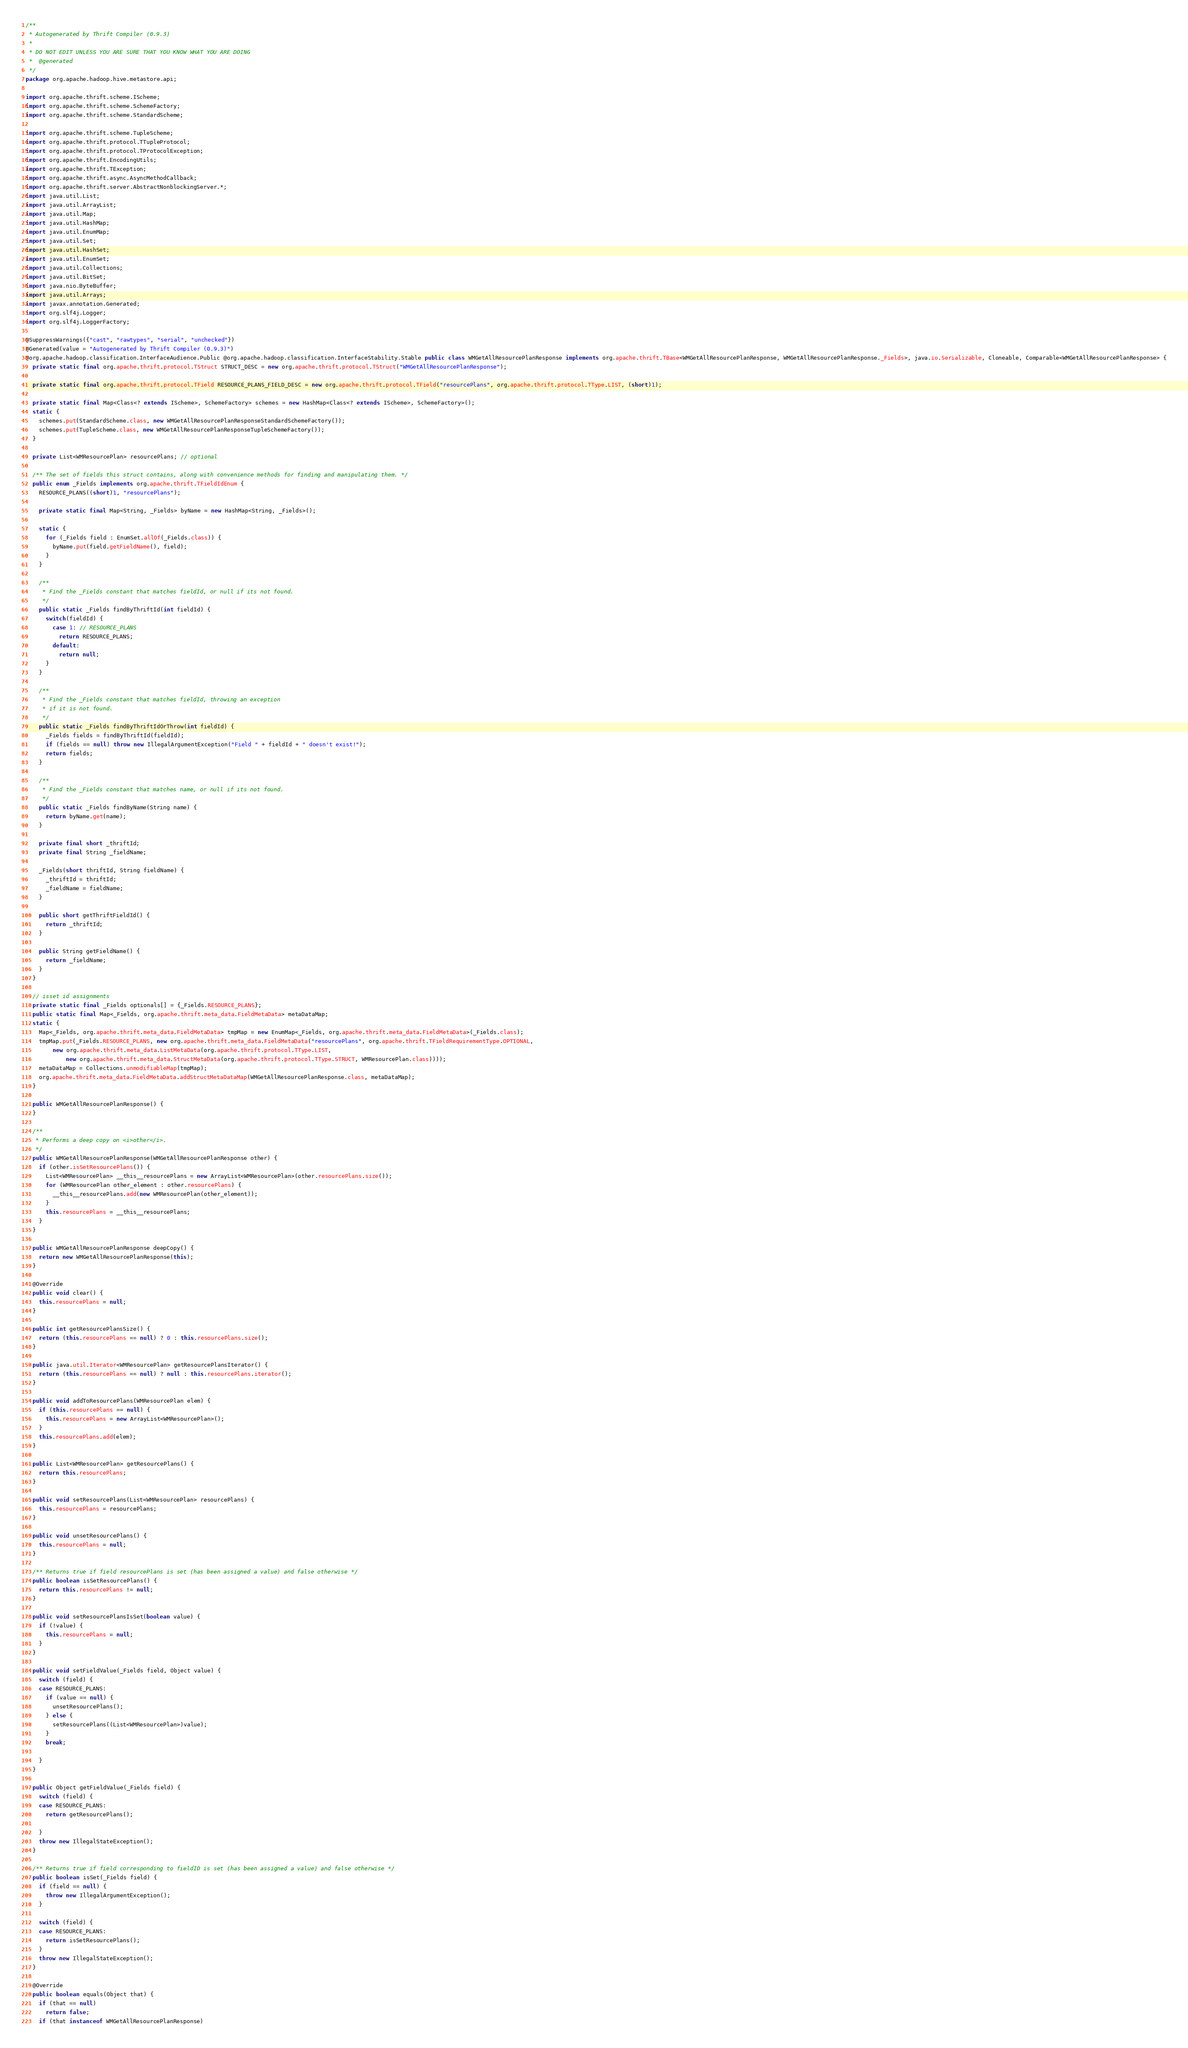Convert code to text. <code><loc_0><loc_0><loc_500><loc_500><_Java_>/**
 * Autogenerated by Thrift Compiler (0.9.3)
 *
 * DO NOT EDIT UNLESS YOU ARE SURE THAT YOU KNOW WHAT YOU ARE DOING
 *  @generated
 */
package org.apache.hadoop.hive.metastore.api;

import org.apache.thrift.scheme.IScheme;
import org.apache.thrift.scheme.SchemeFactory;
import org.apache.thrift.scheme.StandardScheme;

import org.apache.thrift.scheme.TupleScheme;
import org.apache.thrift.protocol.TTupleProtocol;
import org.apache.thrift.protocol.TProtocolException;
import org.apache.thrift.EncodingUtils;
import org.apache.thrift.TException;
import org.apache.thrift.async.AsyncMethodCallback;
import org.apache.thrift.server.AbstractNonblockingServer.*;
import java.util.List;
import java.util.ArrayList;
import java.util.Map;
import java.util.HashMap;
import java.util.EnumMap;
import java.util.Set;
import java.util.HashSet;
import java.util.EnumSet;
import java.util.Collections;
import java.util.BitSet;
import java.nio.ByteBuffer;
import java.util.Arrays;
import javax.annotation.Generated;
import org.slf4j.Logger;
import org.slf4j.LoggerFactory;

@SuppressWarnings({"cast", "rawtypes", "serial", "unchecked"})
@Generated(value = "Autogenerated by Thrift Compiler (0.9.3)")
@org.apache.hadoop.classification.InterfaceAudience.Public @org.apache.hadoop.classification.InterfaceStability.Stable public class WMGetAllResourcePlanResponse implements org.apache.thrift.TBase<WMGetAllResourcePlanResponse, WMGetAllResourcePlanResponse._Fields>, java.io.Serializable, Cloneable, Comparable<WMGetAllResourcePlanResponse> {
  private static final org.apache.thrift.protocol.TStruct STRUCT_DESC = new org.apache.thrift.protocol.TStruct("WMGetAllResourcePlanResponse");

  private static final org.apache.thrift.protocol.TField RESOURCE_PLANS_FIELD_DESC = new org.apache.thrift.protocol.TField("resourcePlans", org.apache.thrift.protocol.TType.LIST, (short)1);

  private static final Map<Class<? extends IScheme>, SchemeFactory> schemes = new HashMap<Class<? extends IScheme>, SchemeFactory>();
  static {
    schemes.put(StandardScheme.class, new WMGetAllResourcePlanResponseStandardSchemeFactory());
    schemes.put(TupleScheme.class, new WMGetAllResourcePlanResponseTupleSchemeFactory());
  }

  private List<WMResourcePlan> resourcePlans; // optional

  /** The set of fields this struct contains, along with convenience methods for finding and manipulating them. */
  public enum _Fields implements org.apache.thrift.TFieldIdEnum {
    RESOURCE_PLANS((short)1, "resourcePlans");

    private static final Map<String, _Fields> byName = new HashMap<String, _Fields>();

    static {
      for (_Fields field : EnumSet.allOf(_Fields.class)) {
        byName.put(field.getFieldName(), field);
      }
    }

    /**
     * Find the _Fields constant that matches fieldId, or null if its not found.
     */
    public static _Fields findByThriftId(int fieldId) {
      switch(fieldId) {
        case 1: // RESOURCE_PLANS
          return RESOURCE_PLANS;
        default:
          return null;
      }
    }

    /**
     * Find the _Fields constant that matches fieldId, throwing an exception
     * if it is not found.
     */
    public static _Fields findByThriftIdOrThrow(int fieldId) {
      _Fields fields = findByThriftId(fieldId);
      if (fields == null) throw new IllegalArgumentException("Field " + fieldId + " doesn't exist!");
      return fields;
    }

    /**
     * Find the _Fields constant that matches name, or null if its not found.
     */
    public static _Fields findByName(String name) {
      return byName.get(name);
    }

    private final short _thriftId;
    private final String _fieldName;

    _Fields(short thriftId, String fieldName) {
      _thriftId = thriftId;
      _fieldName = fieldName;
    }

    public short getThriftFieldId() {
      return _thriftId;
    }

    public String getFieldName() {
      return _fieldName;
    }
  }

  // isset id assignments
  private static final _Fields optionals[] = {_Fields.RESOURCE_PLANS};
  public static final Map<_Fields, org.apache.thrift.meta_data.FieldMetaData> metaDataMap;
  static {
    Map<_Fields, org.apache.thrift.meta_data.FieldMetaData> tmpMap = new EnumMap<_Fields, org.apache.thrift.meta_data.FieldMetaData>(_Fields.class);
    tmpMap.put(_Fields.RESOURCE_PLANS, new org.apache.thrift.meta_data.FieldMetaData("resourcePlans", org.apache.thrift.TFieldRequirementType.OPTIONAL, 
        new org.apache.thrift.meta_data.ListMetaData(org.apache.thrift.protocol.TType.LIST, 
            new org.apache.thrift.meta_data.StructMetaData(org.apache.thrift.protocol.TType.STRUCT, WMResourcePlan.class))));
    metaDataMap = Collections.unmodifiableMap(tmpMap);
    org.apache.thrift.meta_data.FieldMetaData.addStructMetaDataMap(WMGetAllResourcePlanResponse.class, metaDataMap);
  }

  public WMGetAllResourcePlanResponse() {
  }

  /**
   * Performs a deep copy on <i>other</i>.
   */
  public WMGetAllResourcePlanResponse(WMGetAllResourcePlanResponse other) {
    if (other.isSetResourcePlans()) {
      List<WMResourcePlan> __this__resourcePlans = new ArrayList<WMResourcePlan>(other.resourcePlans.size());
      for (WMResourcePlan other_element : other.resourcePlans) {
        __this__resourcePlans.add(new WMResourcePlan(other_element));
      }
      this.resourcePlans = __this__resourcePlans;
    }
  }

  public WMGetAllResourcePlanResponse deepCopy() {
    return new WMGetAllResourcePlanResponse(this);
  }

  @Override
  public void clear() {
    this.resourcePlans = null;
  }

  public int getResourcePlansSize() {
    return (this.resourcePlans == null) ? 0 : this.resourcePlans.size();
  }

  public java.util.Iterator<WMResourcePlan> getResourcePlansIterator() {
    return (this.resourcePlans == null) ? null : this.resourcePlans.iterator();
  }

  public void addToResourcePlans(WMResourcePlan elem) {
    if (this.resourcePlans == null) {
      this.resourcePlans = new ArrayList<WMResourcePlan>();
    }
    this.resourcePlans.add(elem);
  }

  public List<WMResourcePlan> getResourcePlans() {
    return this.resourcePlans;
  }

  public void setResourcePlans(List<WMResourcePlan> resourcePlans) {
    this.resourcePlans = resourcePlans;
  }

  public void unsetResourcePlans() {
    this.resourcePlans = null;
  }

  /** Returns true if field resourcePlans is set (has been assigned a value) and false otherwise */
  public boolean isSetResourcePlans() {
    return this.resourcePlans != null;
  }

  public void setResourcePlansIsSet(boolean value) {
    if (!value) {
      this.resourcePlans = null;
    }
  }

  public void setFieldValue(_Fields field, Object value) {
    switch (field) {
    case RESOURCE_PLANS:
      if (value == null) {
        unsetResourcePlans();
      } else {
        setResourcePlans((List<WMResourcePlan>)value);
      }
      break;

    }
  }

  public Object getFieldValue(_Fields field) {
    switch (field) {
    case RESOURCE_PLANS:
      return getResourcePlans();

    }
    throw new IllegalStateException();
  }

  /** Returns true if field corresponding to fieldID is set (has been assigned a value) and false otherwise */
  public boolean isSet(_Fields field) {
    if (field == null) {
      throw new IllegalArgumentException();
    }

    switch (field) {
    case RESOURCE_PLANS:
      return isSetResourcePlans();
    }
    throw new IllegalStateException();
  }

  @Override
  public boolean equals(Object that) {
    if (that == null)
      return false;
    if (that instanceof WMGetAllResourcePlanResponse)</code> 